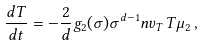Convert formula to latex. <formula><loc_0><loc_0><loc_500><loc_500>\frac { d T } { d t } = - \frac { 2 } { d } g _ { 2 } ( \sigma ) \sigma ^ { d - 1 } n v _ { T } T \mu _ { 2 } \, ,</formula> 